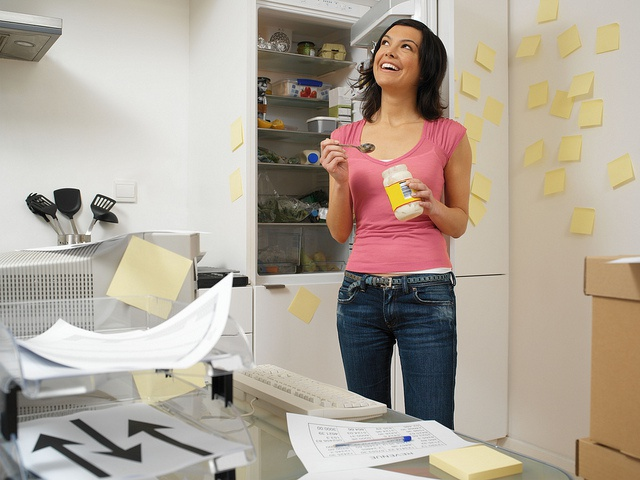Describe the objects in this image and their specific colors. I can see refrigerator in darkgray, lightgray, gray, and black tones, people in darkgray, black, brown, and salmon tones, keyboard in darkgray and lightgray tones, book in darkgray, beige, and tan tones, and bottle in darkgray, lightgray, gold, and tan tones in this image. 